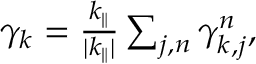Convert formula to latex. <formula><loc_0><loc_0><loc_500><loc_500>\begin{array} { r } { \gamma _ { k } = \frac { k _ { \| } } { | k _ { \| } | } \sum _ { j , n } \gamma _ { k , j } ^ { n } , } \end{array}</formula> 